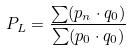<formula> <loc_0><loc_0><loc_500><loc_500>P _ { L } = \frac { \sum ( p _ { n } \cdot q _ { 0 } ) } { \sum ( p _ { 0 } \cdot q _ { 0 } ) }</formula> 